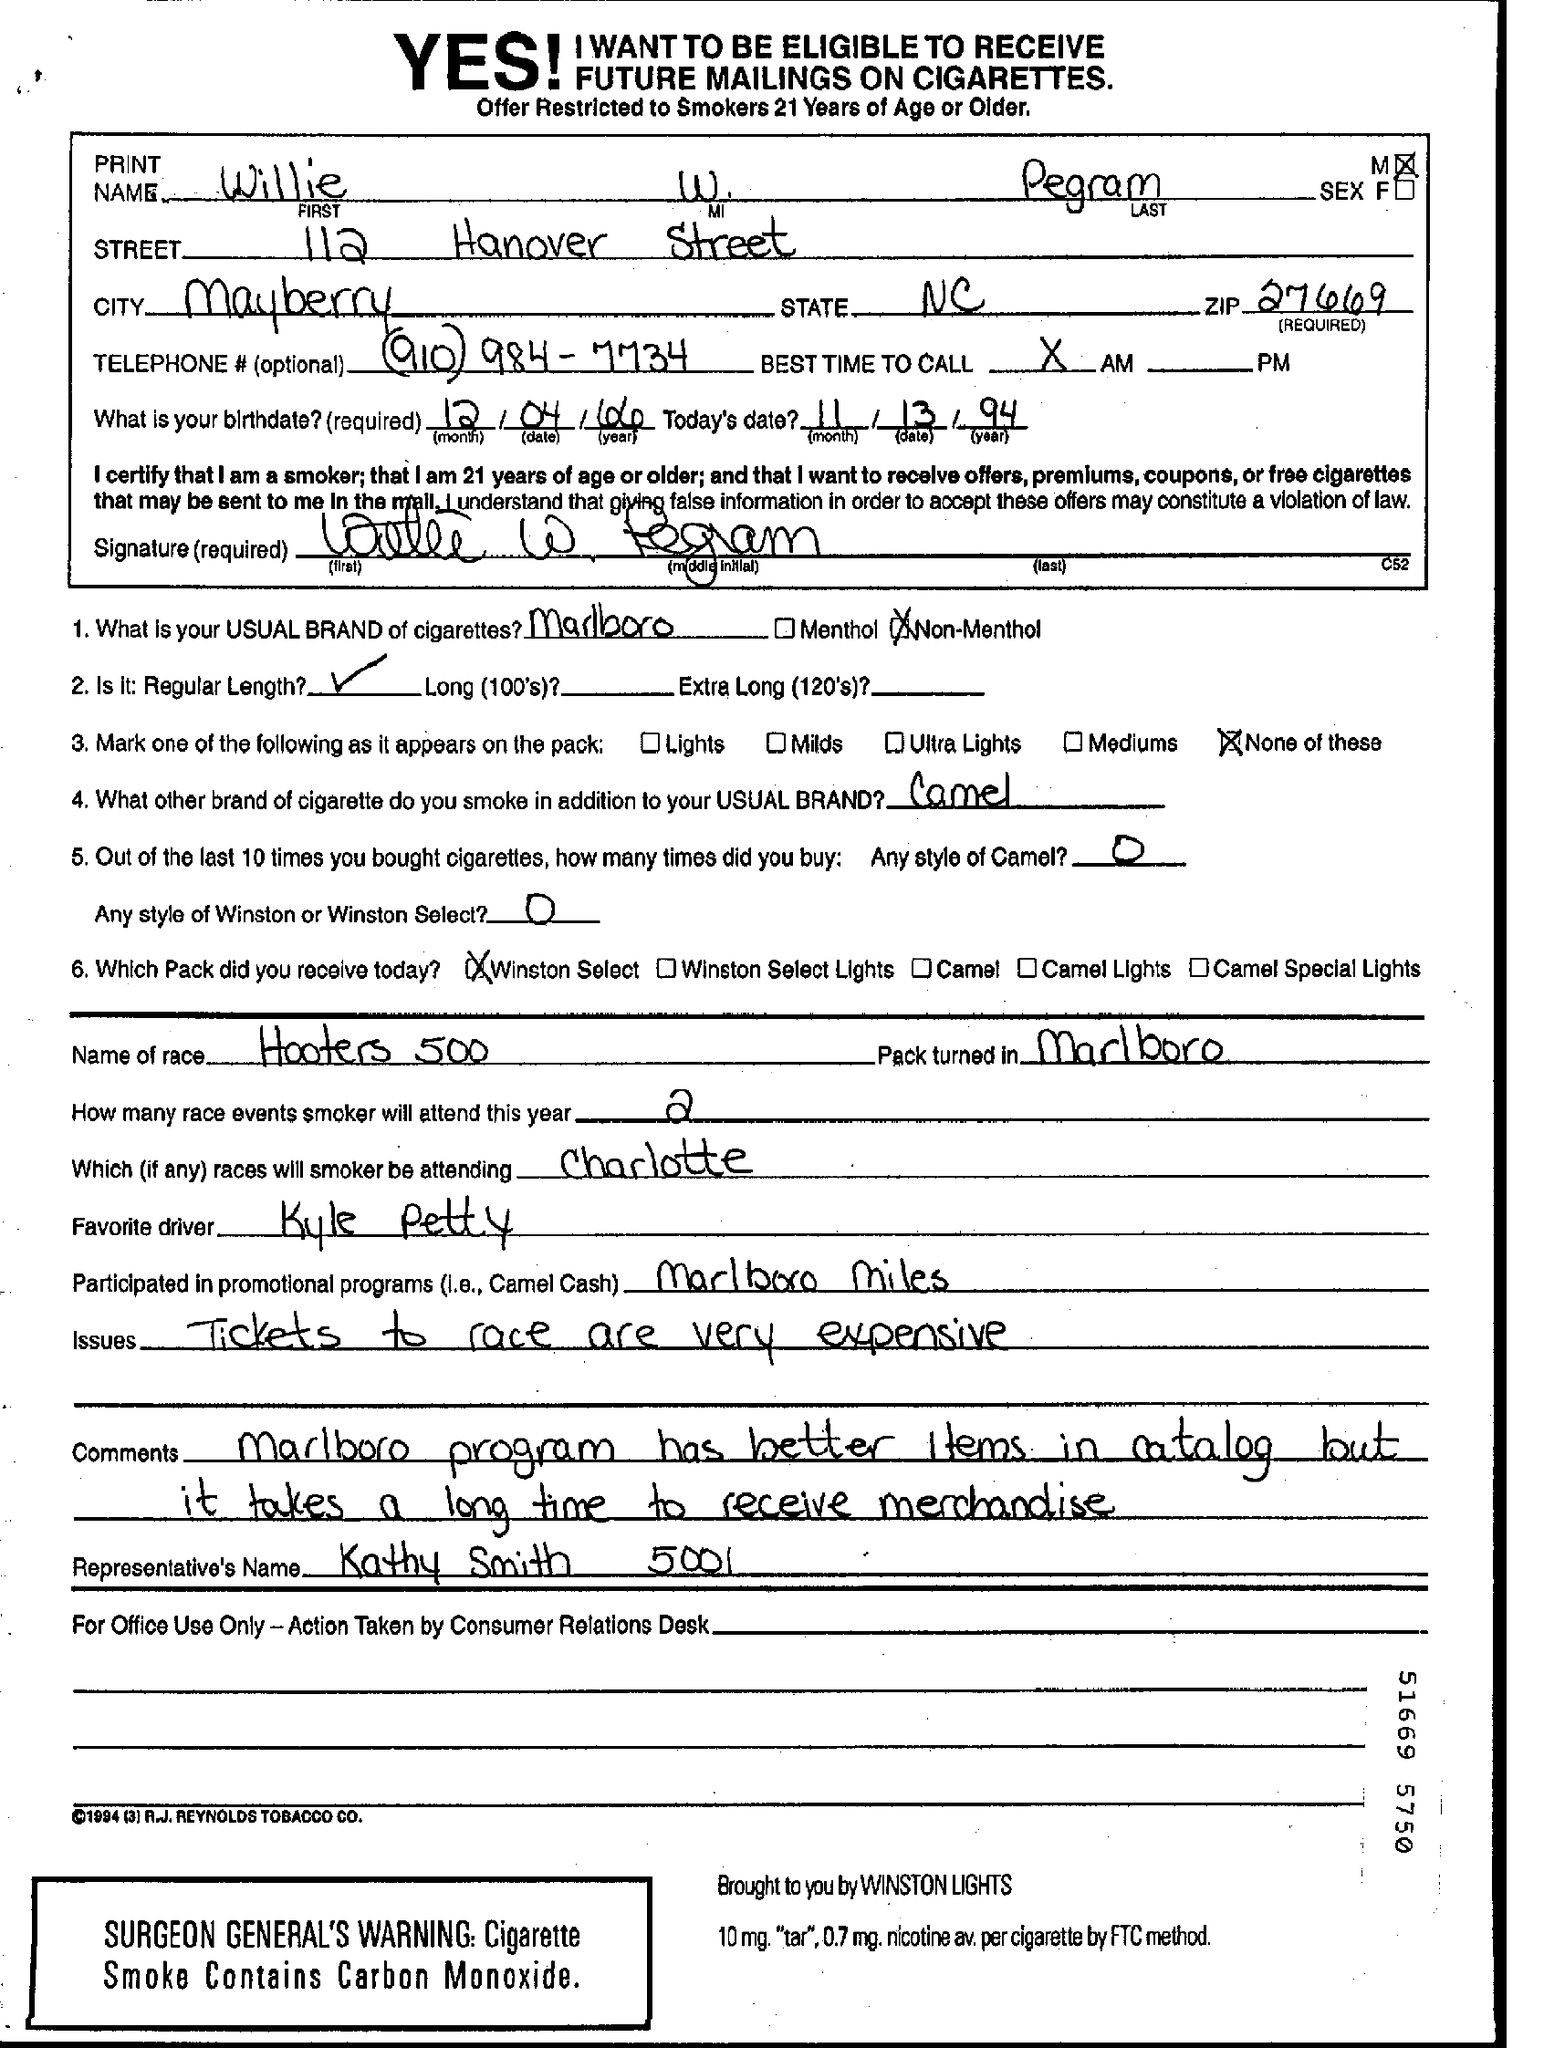What is the First Name?
Provide a succinct answer. Willie. What is the Last Name?
Make the answer very short. Pegram. What is the City?
Give a very brief answer. Mayberry. Which is the state?
Offer a very short reply. NC. What is the Zip?
Your answer should be very brief. 27669. What is the Telephone #?
Keep it short and to the point. (910) 984-7734. What is the birthdate?
Your response must be concise. 12/04/66. What is "Today's Date"?
Your response must be concise. 11/13/94. What is the "Usual Brand of Cigarettes"?
Ensure brevity in your answer.  Marlboro. Who is the Favorite driver?
Provide a succinct answer. Kyle Petty. 